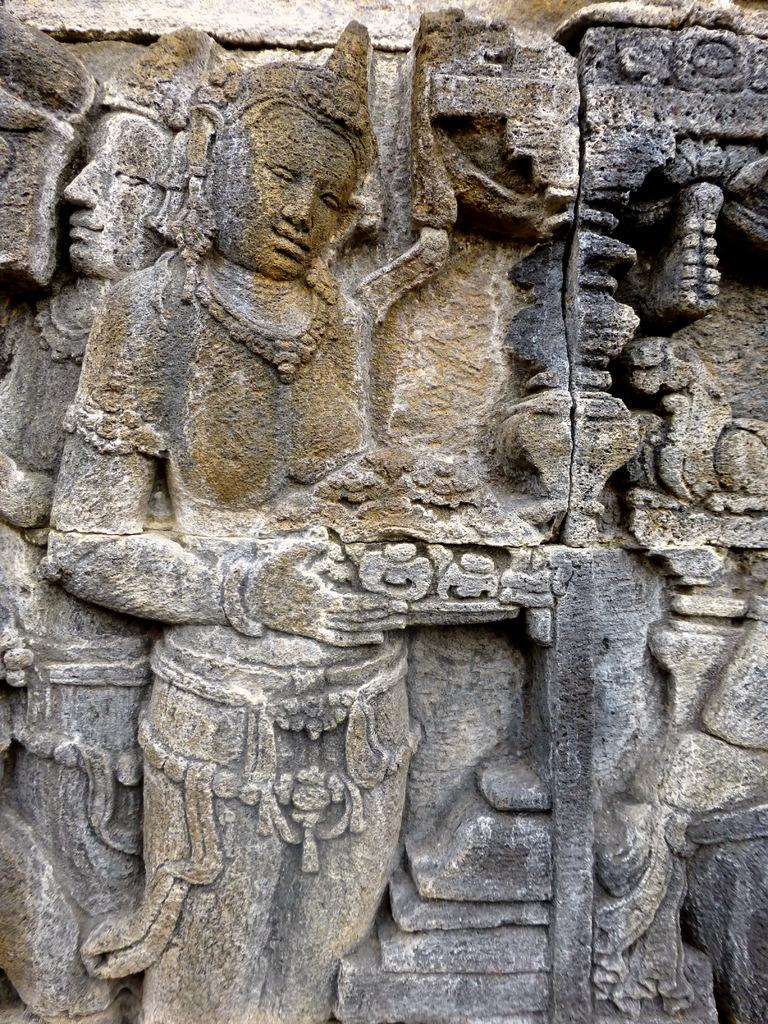What type of objects can be seen in the image? There are sculptures of persons and other objects in the image. Can you describe the sculptures of persons in the image? The sculptures of persons in the image depict human figures. What other types of sculptures can be seen in the image? There are sculptures of other objects in the image, in addition to the sculptures of persons. Is there a deer involved in a fight with one of the sculptures in the image? There is no deer or any indication of a fight present in the image; it only features sculptures of persons and other objects. 